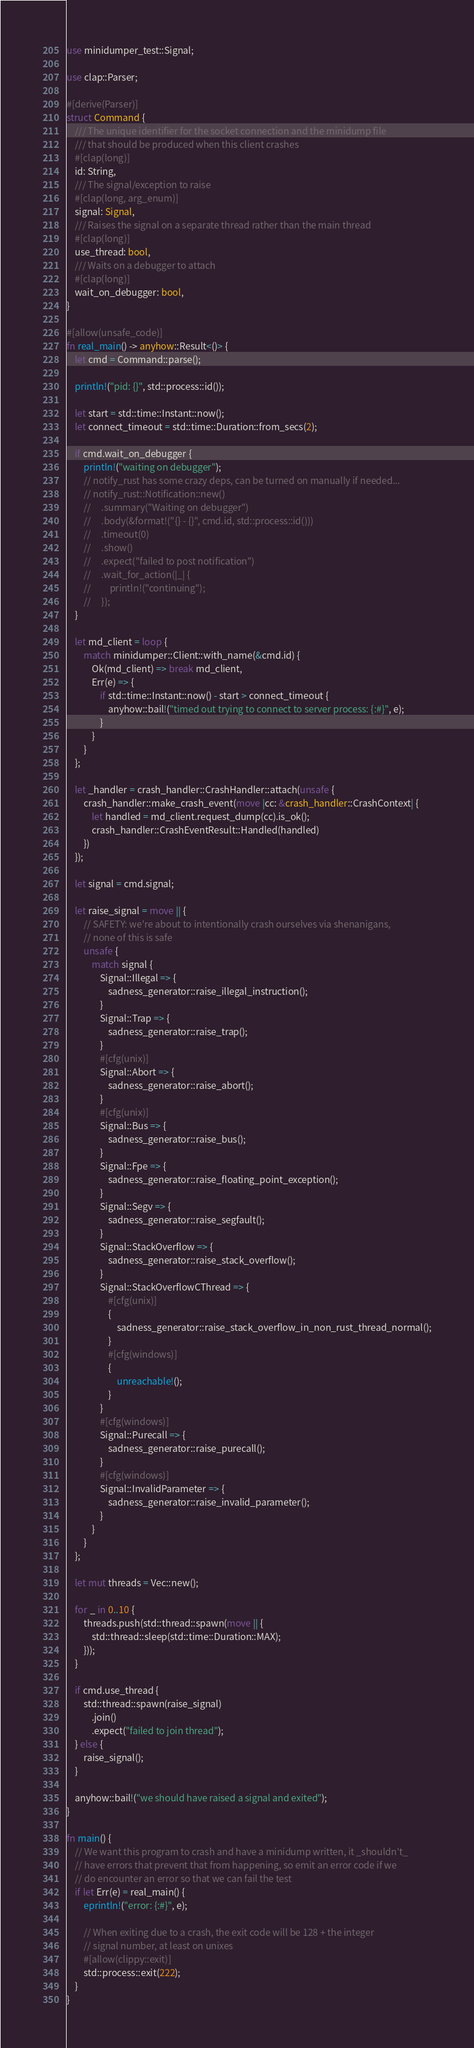Convert code to text. <code><loc_0><loc_0><loc_500><loc_500><_Rust_>use minidumper_test::Signal;

use clap::Parser;

#[derive(Parser)]
struct Command {
    /// The unique identifier for the socket connection and the minidump file
    /// that should be produced when this client crashes
    #[clap(long)]
    id: String,
    /// The signal/exception to raise
    #[clap(long, arg_enum)]
    signal: Signal,
    /// Raises the signal on a separate thread rather than the main thread
    #[clap(long)]
    use_thread: bool,
    /// Waits on a debugger to attach
    #[clap(long)]
    wait_on_debugger: bool,
}

#[allow(unsafe_code)]
fn real_main() -> anyhow::Result<()> {
    let cmd = Command::parse();

    println!("pid: {}", std::process::id());

    let start = std::time::Instant::now();
    let connect_timeout = std::time::Duration::from_secs(2);

    if cmd.wait_on_debugger {
        println!("waiting on debugger");
        // notify_rust has some crazy deps, can be turned on manually if needed...
        // notify_rust::Notification::new()
        //     .summary("Waiting on debugger")
        //     .body(&format!("{} - {}", cmd.id, std::process::id()))
        //     .timeout(0)
        //     .show()
        //     .expect("failed to post notification")
        //     .wait_for_action(|_| {
        //         println!("continuing");
        //     });
    }

    let md_client = loop {
        match minidumper::Client::with_name(&cmd.id) {
            Ok(md_client) => break md_client,
            Err(e) => {
                if std::time::Instant::now() - start > connect_timeout {
                    anyhow::bail!("timed out trying to connect to server process: {:#}", e);
                }
            }
        }
    };

    let _handler = crash_handler::CrashHandler::attach(unsafe {
        crash_handler::make_crash_event(move |cc: &crash_handler::CrashContext| {
            let handled = md_client.request_dump(cc).is_ok();
            crash_handler::CrashEventResult::Handled(handled)
        })
    });

    let signal = cmd.signal;

    let raise_signal = move || {
        // SAFETY: we're about to intentionally crash ourselves via shenanigans,
        // none of this is safe
        unsafe {
            match signal {
                Signal::Illegal => {
                    sadness_generator::raise_illegal_instruction();
                }
                Signal::Trap => {
                    sadness_generator::raise_trap();
                }
                #[cfg(unix)]
                Signal::Abort => {
                    sadness_generator::raise_abort();
                }
                #[cfg(unix)]
                Signal::Bus => {
                    sadness_generator::raise_bus();
                }
                Signal::Fpe => {
                    sadness_generator::raise_floating_point_exception();
                }
                Signal::Segv => {
                    sadness_generator::raise_segfault();
                }
                Signal::StackOverflow => {
                    sadness_generator::raise_stack_overflow();
                }
                Signal::StackOverflowCThread => {
                    #[cfg(unix)]
                    {
                        sadness_generator::raise_stack_overflow_in_non_rust_thread_normal();
                    }
                    #[cfg(windows)]
                    {
                        unreachable!();
                    }
                }
                #[cfg(windows)]
                Signal::Purecall => {
                    sadness_generator::raise_purecall();
                }
                #[cfg(windows)]
                Signal::InvalidParameter => {
                    sadness_generator::raise_invalid_parameter();
                }
            }
        }
    };

    let mut threads = Vec::new();

    for _ in 0..10 {
        threads.push(std::thread::spawn(move || {
            std::thread::sleep(std::time::Duration::MAX);
        }));
    }

    if cmd.use_thread {
        std::thread::spawn(raise_signal)
            .join()
            .expect("failed to join thread");
    } else {
        raise_signal();
    }

    anyhow::bail!("we should have raised a signal and exited");
}

fn main() {
    // We want this program to crash and have a minidump written, it _shouldn't_
    // have errors that prevent that from happening, so emit an error code if we
    // do encounter an error so that we can fail the test
    if let Err(e) = real_main() {
        eprintln!("error: {:#}", e);

        // When exiting due to a crash, the exit code will be 128 + the integer
        // signal number, at least on unixes
        #[allow(clippy::exit)]
        std::process::exit(222);
    }
}
</code> 